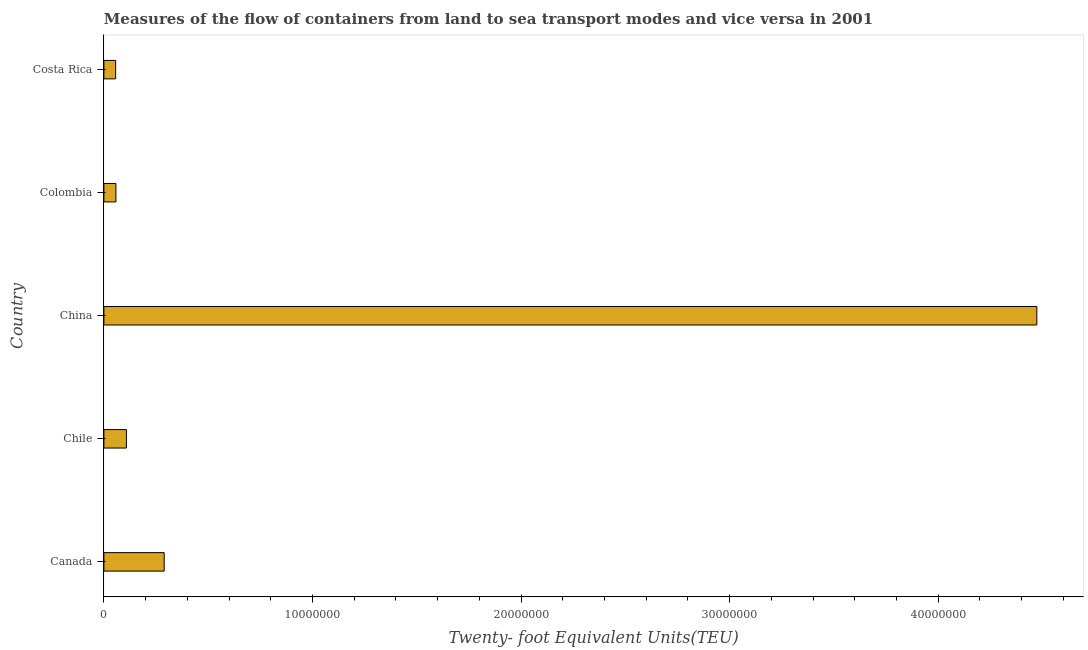Does the graph contain any zero values?
Your answer should be very brief. No. Does the graph contain grids?
Give a very brief answer. No. What is the title of the graph?
Offer a very short reply. Measures of the flow of containers from land to sea transport modes and vice versa in 2001. What is the label or title of the X-axis?
Offer a very short reply. Twenty- foot Equivalent Units(TEU). What is the container port traffic in Costa Rica?
Offer a terse response. 5.64e+05. Across all countries, what is the maximum container port traffic?
Your answer should be very brief. 4.47e+07. Across all countries, what is the minimum container port traffic?
Keep it short and to the point. 5.64e+05. In which country was the container port traffic maximum?
Ensure brevity in your answer.  China. What is the sum of the container port traffic?
Keep it short and to the point. 4.98e+07. What is the difference between the container port traffic in Chile and Colombia?
Offer a terse response. 5.04e+05. What is the average container port traffic per country?
Your response must be concise. 9.97e+06. What is the median container port traffic?
Provide a succinct answer. 1.08e+06. In how many countries, is the container port traffic greater than 38000000 TEU?
Provide a short and direct response. 1. What is the ratio of the container port traffic in Canada to that in Chile?
Offer a terse response. 2.67. Is the difference between the container port traffic in Canada and Chile greater than the difference between any two countries?
Provide a succinct answer. No. What is the difference between the highest and the second highest container port traffic?
Ensure brevity in your answer.  4.18e+07. Is the sum of the container port traffic in Chile and Colombia greater than the maximum container port traffic across all countries?
Offer a terse response. No. What is the difference between the highest and the lowest container port traffic?
Keep it short and to the point. 4.42e+07. In how many countries, is the container port traffic greater than the average container port traffic taken over all countries?
Ensure brevity in your answer.  1. How many bars are there?
Provide a short and direct response. 5. How many countries are there in the graph?
Your answer should be very brief. 5. What is the difference between two consecutive major ticks on the X-axis?
Your answer should be compact. 1.00e+07. Are the values on the major ticks of X-axis written in scientific E-notation?
Offer a terse response. No. What is the Twenty- foot Equivalent Units(TEU) of Canada?
Offer a very short reply. 2.89e+06. What is the Twenty- foot Equivalent Units(TEU) in Chile?
Give a very brief answer. 1.08e+06. What is the Twenty- foot Equivalent Units(TEU) of China?
Make the answer very short. 4.47e+07. What is the Twenty- foot Equivalent Units(TEU) of Colombia?
Keep it short and to the point. 5.77e+05. What is the Twenty- foot Equivalent Units(TEU) in Costa Rica?
Keep it short and to the point. 5.64e+05. What is the difference between the Twenty- foot Equivalent Units(TEU) in Canada and Chile?
Keep it short and to the point. 1.81e+06. What is the difference between the Twenty- foot Equivalent Units(TEU) in Canada and China?
Your answer should be very brief. -4.18e+07. What is the difference between the Twenty- foot Equivalent Units(TEU) in Canada and Colombia?
Ensure brevity in your answer.  2.31e+06. What is the difference between the Twenty- foot Equivalent Units(TEU) in Canada and Costa Rica?
Provide a succinct answer. 2.33e+06. What is the difference between the Twenty- foot Equivalent Units(TEU) in Chile and China?
Your response must be concise. -4.36e+07. What is the difference between the Twenty- foot Equivalent Units(TEU) in Chile and Colombia?
Provide a short and direct response. 5.04e+05. What is the difference between the Twenty- foot Equivalent Units(TEU) in Chile and Costa Rica?
Your answer should be very brief. 5.17e+05. What is the difference between the Twenty- foot Equivalent Units(TEU) in China and Colombia?
Ensure brevity in your answer.  4.41e+07. What is the difference between the Twenty- foot Equivalent Units(TEU) in China and Costa Rica?
Provide a short and direct response. 4.42e+07. What is the difference between the Twenty- foot Equivalent Units(TEU) in Colombia and Costa Rica?
Your answer should be very brief. 1.32e+04. What is the ratio of the Twenty- foot Equivalent Units(TEU) in Canada to that in Chile?
Provide a short and direct response. 2.67. What is the ratio of the Twenty- foot Equivalent Units(TEU) in Canada to that in China?
Your answer should be compact. 0.07. What is the ratio of the Twenty- foot Equivalent Units(TEU) in Canada to that in Colombia?
Your answer should be compact. 5.01. What is the ratio of the Twenty- foot Equivalent Units(TEU) in Canada to that in Costa Rica?
Make the answer very short. 5.13. What is the ratio of the Twenty- foot Equivalent Units(TEU) in Chile to that in China?
Ensure brevity in your answer.  0.02. What is the ratio of the Twenty- foot Equivalent Units(TEU) in Chile to that in Colombia?
Give a very brief answer. 1.87. What is the ratio of the Twenty- foot Equivalent Units(TEU) in Chile to that in Costa Rica?
Ensure brevity in your answer.  1.92. What is the ratio of the Twenty- foot Equivalent Units(TEU) in China to that in Colombia?
Give a very brief answer. 77.51. What is the ratio of the Twenty- foot Equivalent Units(TEU) in China to that in Costa Rica?
Your response must be concise. 79.33. What is the ratio of the Twenty- foot Equivalent Units(TEU) in Colombia to that in Costa Rica?
Your answer should be compact. 1.02. 